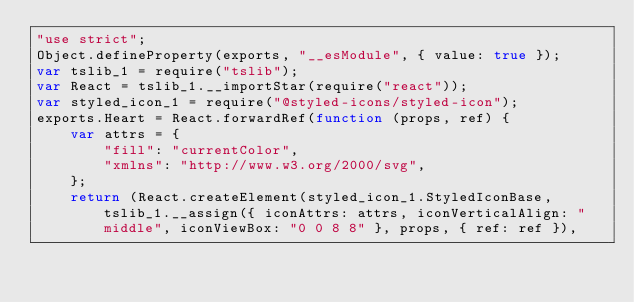<code> <loc_0><loc_0><loc_500><loc_500><_JavaScript_>"use strict";
Object.defineProperty(exports, "__esModule", { value: true });
var tslib_1 = require("tslib");
var React = tslib_1.__importStar(require("react"));
var styled_icon_1 = require("@styled-icons/styled-icon");
exports.Heart = React.forwardRef(function (props, ref) {
    var attrs = {
        "fill": "currentColor",
        "xmlns": "http://www.w3.org/2000/svg",
    };
    return (React.createElement(styled_icon_1.StyledIconBase, tslib_1.__assign({ iconAttrs: attrs, iconVerticalAlign: "middle", iconViewBox: "0 0 8 8" }, props, { ref: ref }),</code> 